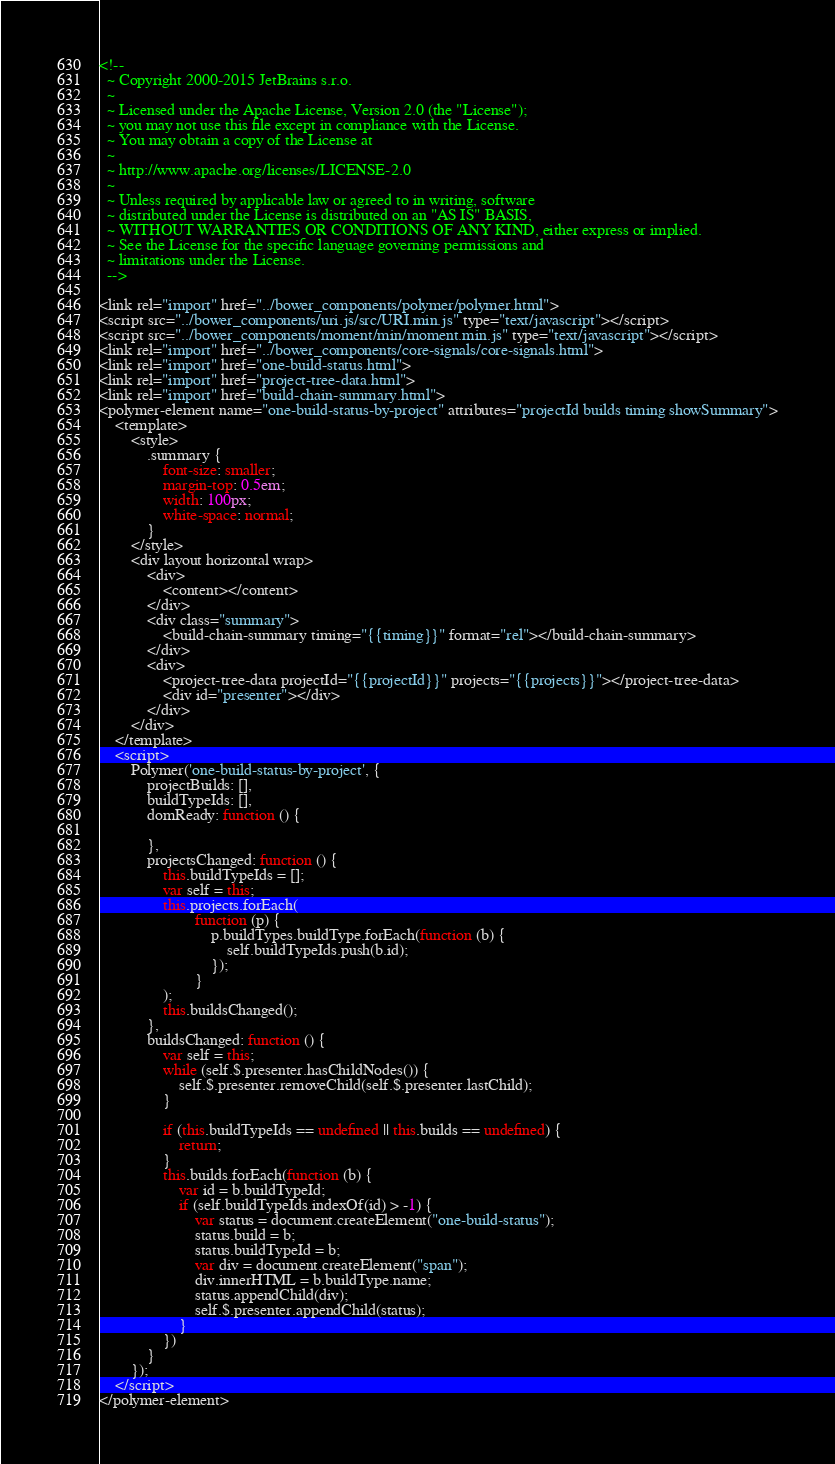<code> <loc_0><loc_0><loc_500><loc_500><_HTML_><!--
  ~ Copyright 2000-2015 JetBrains s.r.o.
  ~
  ~ Licensed under the Apache License, Version 2.0 (the "License");
  ~ you may not use this file except in compliance with the License.
  ~ You may obtain a copy of the License at
  ~
  ~ http://www.apache.org/licenses/LICENSE-2.0
  ~
  ~ Unless required by applicable law or agreed to in writing, software
  ~ distributed under the License is distributed on an "AS IS" BASIS,
  ~ WITHOUT WARRANTIES OR CONDITIONS OF ANY KIND, either express or implied.
  ~ See the License for the specific language governing permissions and
  ~ limitations under the License.
  -->

<link rel="import" href="../bower_components/polymer/polymer.html">
<script src="../bower_components/uri.js/src/URI.min.js" type="text/javascript"></script>
<script src="../bower_components/moment/min/moment.min.js" type="text/javascript"></script>
<link rel="import" href="../bower_components/core-signals/core-signals.html">
<link rel="import" href="one-build-status.html">
<link rel="import" href="project-tree-data.html">
<link rel="import" href="build-chain-summary.html">
<polymer-element name="one-build-status-by-project" attributes="projectId builds timing showSummary">
    <template>
        <style>
            .summary {
                font-size: smaller;
                margin-top: 0.5em;
                width: 100px;
                white-space: normal;
            }
        </style>
        <div layout horizontal wrap>
            <div>
                <content></content>
            </div>
            <div class="summary">
                <build-chain-summary timing="{{timing}}" format="rel"></build-chain-summary>
            </div>
            <div>
                <project-tree-data projectId="{{projectId}}" projects="{{projects}}"></project-tree-data>
                <div id="presenter"></div>
            </div>
        </div>
    </template>
    <script>
        Polymer('one-build-status-by-project', {
            projectBuilds: [],
            buildTypeIds: [],
            domReady: function () {

            },
            projectsChanged: function () {
                this.buildTypeIds = [];
                var self = this;
                this.projects.forEach(
                        function (p) {
                            p.buildTypes.buildType.forEach(function (b) {
                                self.buildTypeIds.push(b.id);
                            });
                        }
                );
                this.buildsChanged();
            },
            buildsChanged: function () {
                var self = this;
                while (self.$.presenter.hasChildNodes()) {
                    self.$.presenter.removeChild(self.$.presenter.lastChild);
                }

                if (this.buildTypeIds == undefined || this.builds == undefined) {
                    return;
                }
                this.builds.forEach(function (b) {
                    var id = b.buildTypeId;
                    if (self.buildTypeIds.indexOf(id) > -1) {
                        var status = document.createElement("one-build-status");
                        status.build = b;
                        status.buildTypeId = b;
                        var div = document.createElement("span");
                        div.innerHTML = b.buildType.name;
                        status.appendChild(div);
                        self.$.presenter.appendChild(status);
                    }
                })
            }
        });
    </script>
</polymer-element></code> 